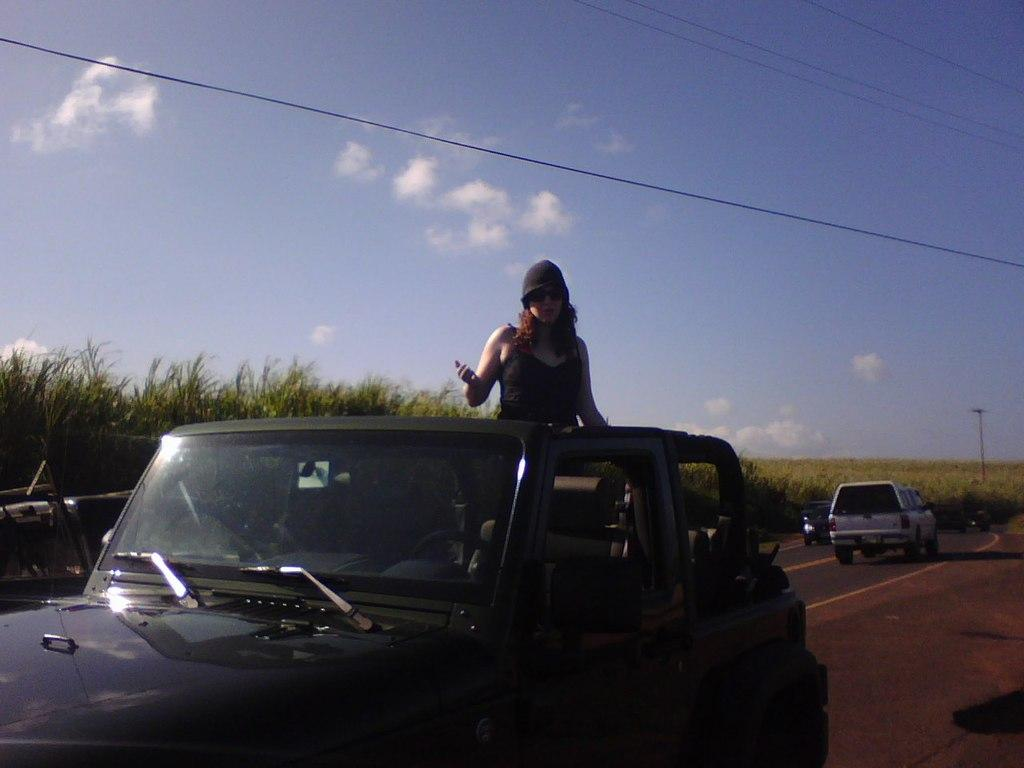What is the main subject of the image? There is a car on the road in the image. Who is inside the car? A woman is standing inside the car. What can be seen in the background of the image? There is a farm and two other cars in the background of the image. What is visible in the sky in the image? The sky is visible in the background of the image, and clouds are present. Can you hear the woman whistling while standing inside the car in the image? There is no indication of any sound in the image, including whistling. 